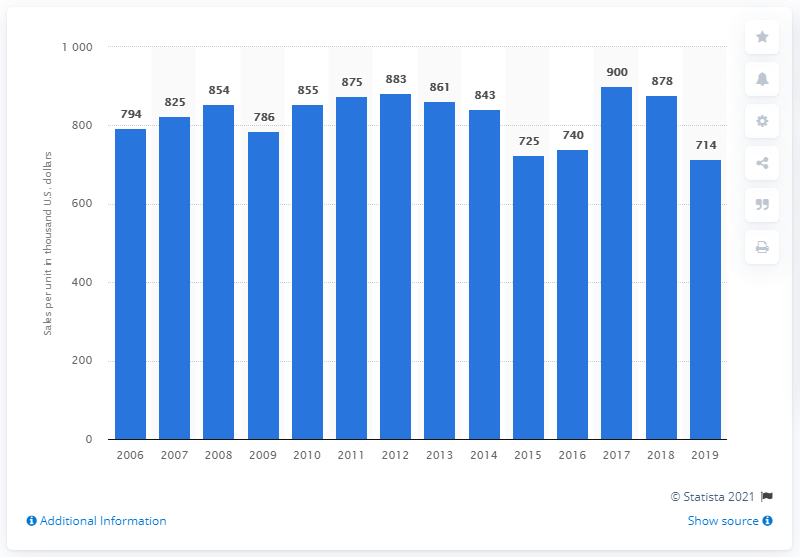Highlight a few significant elements in this photo. In the previous year, Pizza Hut's sales per unit were approximately 878. In 2019, Pizza Hut's sales per unit were approximately 714. In 2019, Pizza Hut achieved its highest sales per store, with an average of 900. 